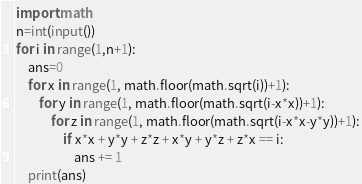Convert code to text. <code><loc_0><loc_0><loc_500><loc_500><_Python_>import math
n=int(input())
for i in range(1,n+1):
    ans=0
    for x in range(1, math.floor(math.sqrt(i))+1):
        for y in range(1, math.floor(math.sqrt(i-x*x))+1):
            for z in range(1, math.floor(math.sqrt(i-x*x-y*y))+1):
                if x*x + y*y + z*z + x*y + y*z + z*x == i:
                    ans += 1
    print(ans)</code> 